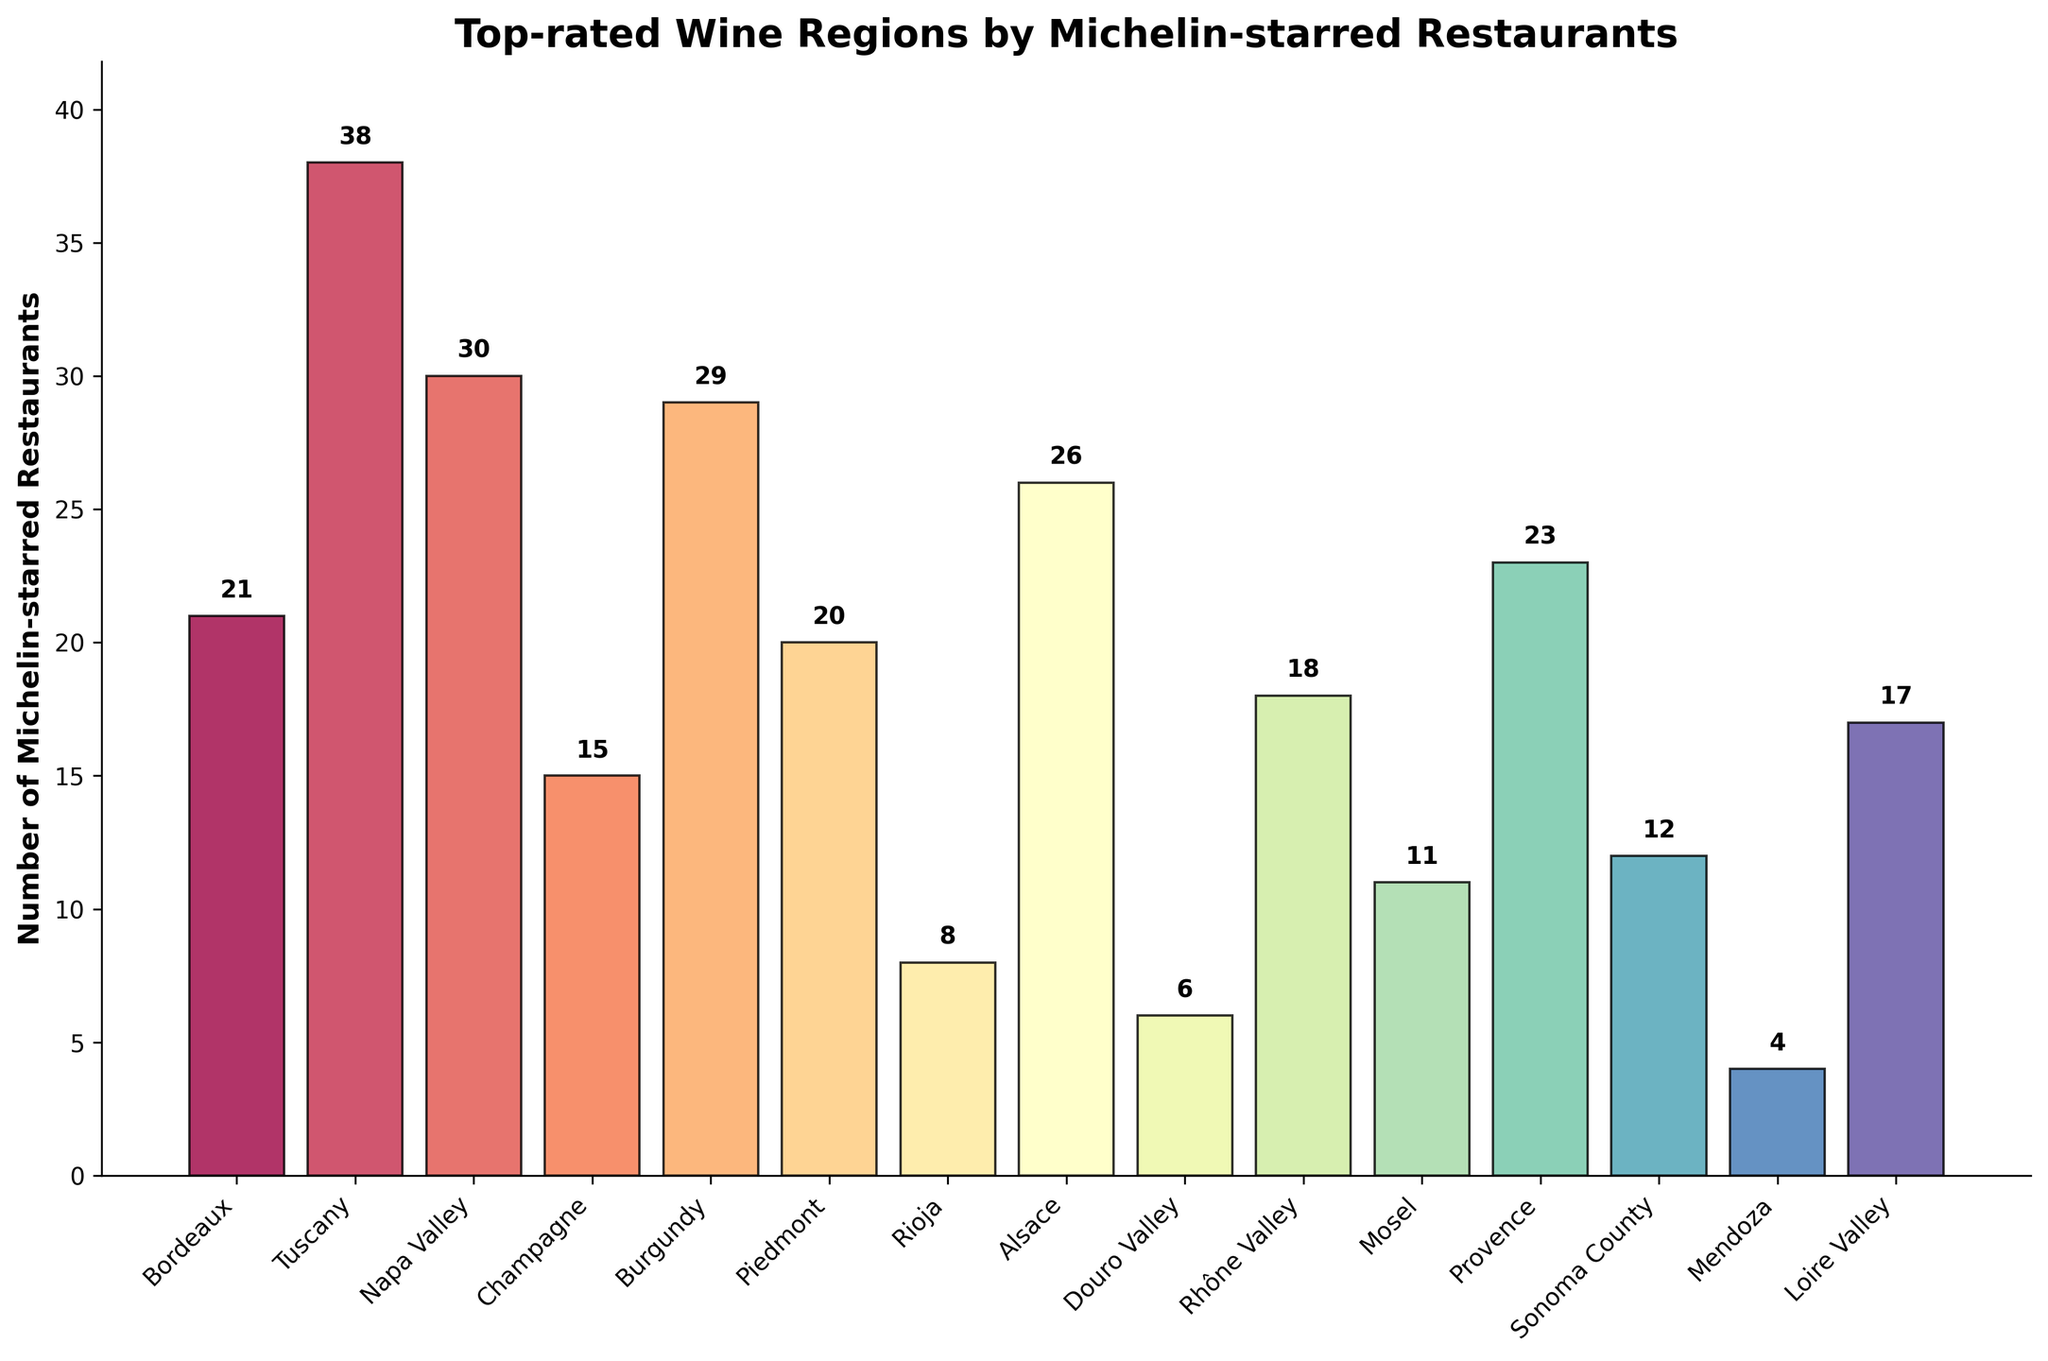Which wine region has the highest number of Michelin-starred restaurants? The tallest bar in the chart corresponds to the region with the highest number of Michelin-starred restaurants, which is Tuscany.
Answer: Tuscany Compare Bordeaux and Piedmont. Which region has more Michelin-starred restaurants? By observing the heights of the bars for Bordeaux and Piedmont, Bordeaux has 21, and Piedmont has 20.
Answer: Bordeaux What is the difference in the number of Michelin-starred restaurants between Napa Valley and Alsace? Napa Valley has 30 restaurants, while Alsace has 26. The difference is 30 - 26.
Answer: 4 What's the total number of Michelin-starred restaurants in Rhône Valley, Loire Valley, and Mosel combined? Rhône Valley has 18, Loire Valley has 17, and Mosel has 11. The sum is 18 + 17 + 11.
Answer: 46 Of the regions listed, which has the fewest Michelin-starred restaurants? The shortest bar in the chart corresponds to the region with the fewest Michelin-starred restaurants, which is Mendoza with 4.
Answer: Mendoza How many more Michelin-starred restaurants does Provence have compared to Sonoma County? Provence has 23 restaurants, while Sonoma County has 12. The difference is 23 - 12.
Answer: 11 What is the average number of Michelin-starred restaurants for Bordeaux, Champagne, and Burgundy? Bordeaux has 21, Champagne has 15, and Burgundy has 29. The sum is 21 + 15 + 29 = 65. The average is 65 / 3.
Answer: 21.67 If the total number of Michelin-starred restaurants needs to be an average of 20 across all regions, how many more restaurants would Douro Valley need? Douro Valley currently has 6 restaurants. To have an average of 20 across all regions, the total required is 15 regions * 20 = 300 restaurants. Since there are currently 278 (sum of all restaurants), Douro Valley would need 300 - 278 = 22 additional restaurants.
Answer: 22 How many regions have more than 20 Michelin-starred restaurants? By counting the bars that have a height representing more than 20 restaurants: Tuscany, Napa Valley, Burgundy, Alsace, Provence. There are 5 regions.
Answer: 5 Which regions have exactly 38 Michelin-starred restaurants? The bar with a height representing exactly 38 restaurants corresponds to Tuscany.
Answer: Tuscany 